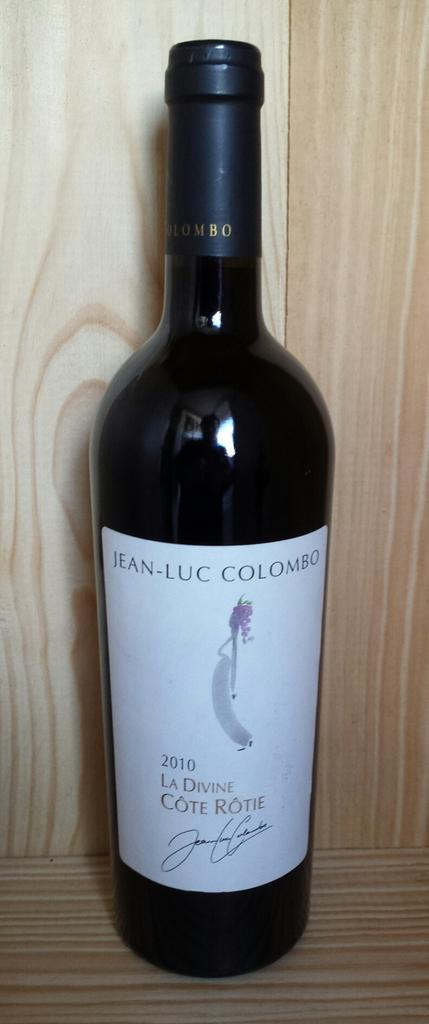<image>
Share a concise interpretation of the image provided. A bottle of Jean Luc Colombo 2010 La Divine Cote Rotie sits on a wooden shelf. 